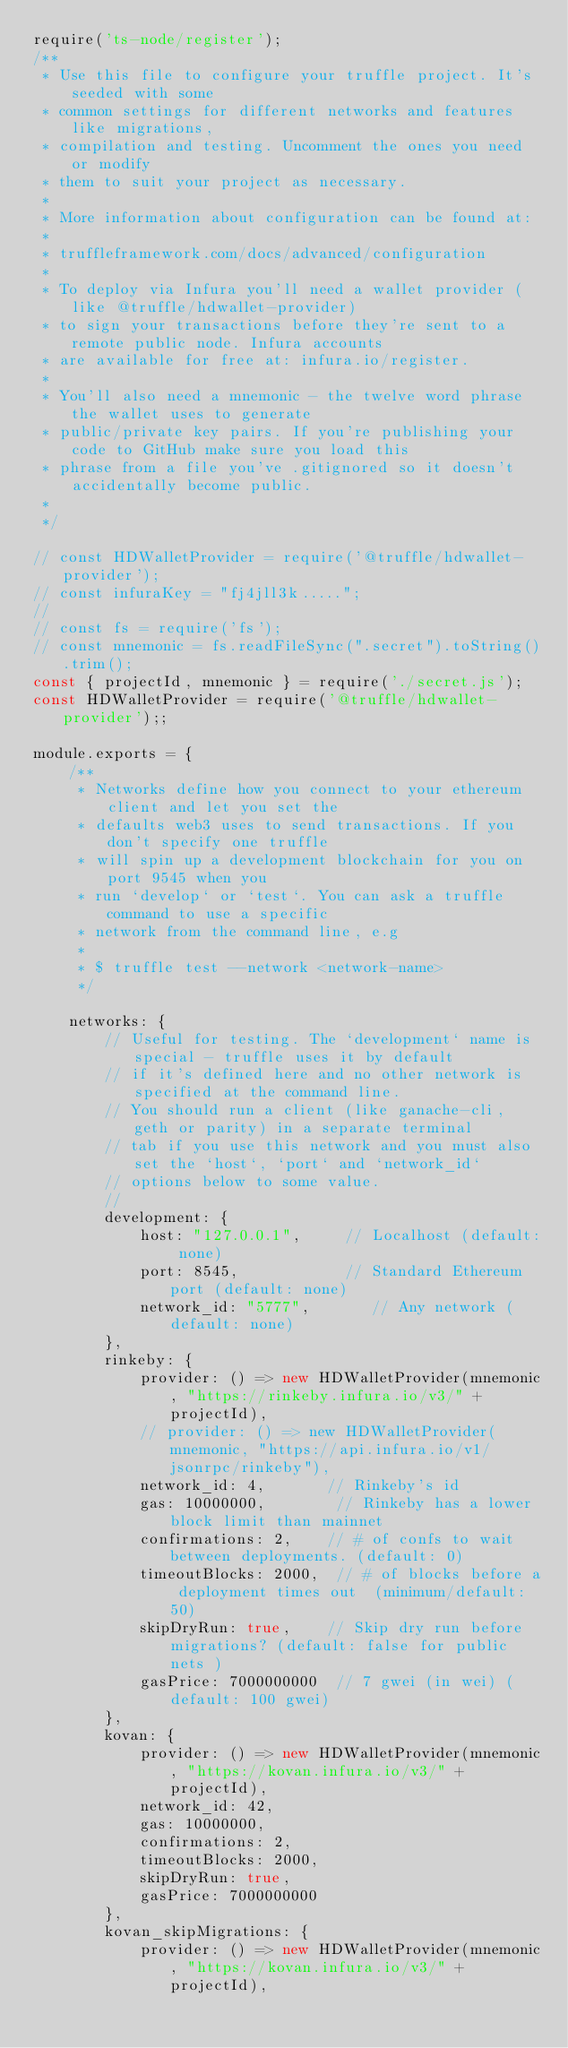<code> <loc_0><loc_0><loc_500><loc_500><_JavaScript_>require('ts-node/register');
/**
 * Use this file to configure your truffle project. It's seeded with some
 * common settings for different networks and features like migrations,
 * compilation and testing. Uncomment the ones you need or modify
 * them to suit your project as necessary.
 *
 * More information about configuration can be found at:
 *
 * truffleframework.com/docs/advanced/configuration
 *
 * To deploy via Infura you'll need a wallet provider (like @truffle/hdwallet-provider)
 * to sign your transactions before they're sent to a remote public node. Infura accounts
 * are available for free at: infura.io/register.
 *
 * You'll also need a mnemonic - the twelve word phrase the wallet uses to generate
 * public/private key pairs. If you're publishing your code to GitHub make sure you load this
 * phrase from a file you've .gitignored so it doesn't accidentally become public.
 *
 */

// const HDWalletProvider = require('@truffle/hdwallet-provider');
// const infuraKey = "fj4jll3k.....";
//
// const fs = require('fs');
// const mnemonic = fs.readFileSync(".secret").toString().trim();
const { projectId, mnemonic } = require('./secret.js');
const HDWalletProvider = require('@truffle/hdwallet-provider');;

module.exports = {
    /**
     * Networks define how you connect to your ethereum client and let you set the
     * defaults web3 uses to send transactions. If you don't specify one truffle
     * will spin up a development blockchain for you on port 9545 when you
     * run `develop` or `test`. You can ask a truffle command to use a specific
     * network from the command line, e.g
     *
     * $ truffle test --network <network-name>
     */

    networks: {
        // Useful for testing. The `development` name is special - truffle uses it by default
        // if it's defined here and no other network is specified at the command line.
        // You should run a client (like ganache-cli, geth or parity) in a separate terminal
        // tab if you use this network and you must also set the `host`, `port` and `network_id`
        // options below to some value.
        //
        development: {
            host: "127.0.0.1",     // Localhost (default: none)
            port: 8545,            // Standard Ethereum port (default: none)
            network_id: "5777",       // Any network (default: none)
        },
        rinkeby: {
            provider: () => new HDWalletProvider(mnemonic, "https://rinkeby.infura.io/v3/" + projectId),
            // provider: () => new HDWalletProvider(mnemonic, "https://api.infura.io/v1/jsonrpc/rinkeby"),
            network_id: 4,       // Rinkeby's id
            gas: 10000000,        // Rinkeby has a lower block limit than mainnet
            confirmations: 2,    // # of confs to wait between deployments. (default: 0)
            timeoutBlocks: 2000,  // # of blocks before a deployment times out  (minimum/default: 50)
            skipDryRun: true,    // Skip dry run before migrations? (default: false for public nets )
            gasPrice: 7000000000  // 7 gwei (in wei) (default: 100 gwei)
        },
        kovan: {
            provider: () => new HDWalletProvider(mnemonic, "https://kovan.infura.io/v3/" + projectId),
            network_id: 42,
            gas: 10000000,
            confirmations: 2,
            timeoutBlocks: 2000,
            skipDryRun: true,
            gasPrice: 7000000000
        },
        kovan_skipMigrations: {
            provider: () => new HDWalletProvider(mnemonic, "https://kovan.infura.io/v3/" + projectId),</code> 